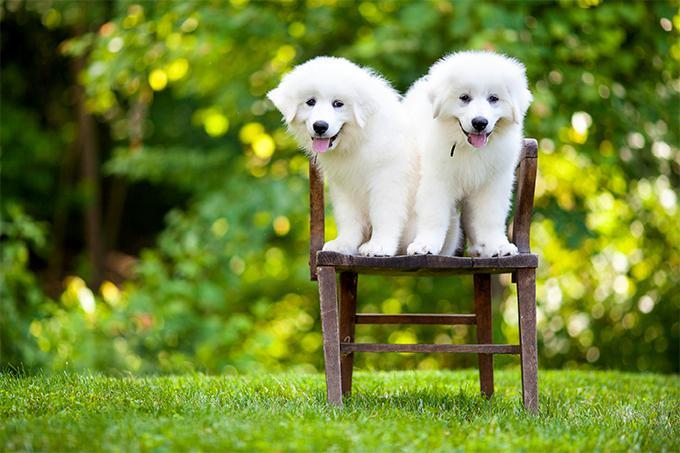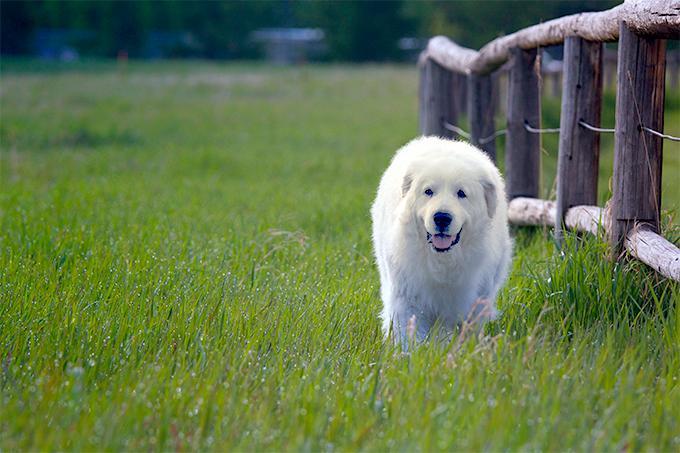The first image is the image on the left, the second image is the image on the right. Evaluate the accuracy of this statement regarding the images: "There is a dog standing next to a fence.". Is it true? Answer yes or no. Yes. The first image is the image on the left, the second image is the image on the right. For the images shown, is this caption "An image features exactly two nearly identical dogs." true? Answer yes or no. Yes. 